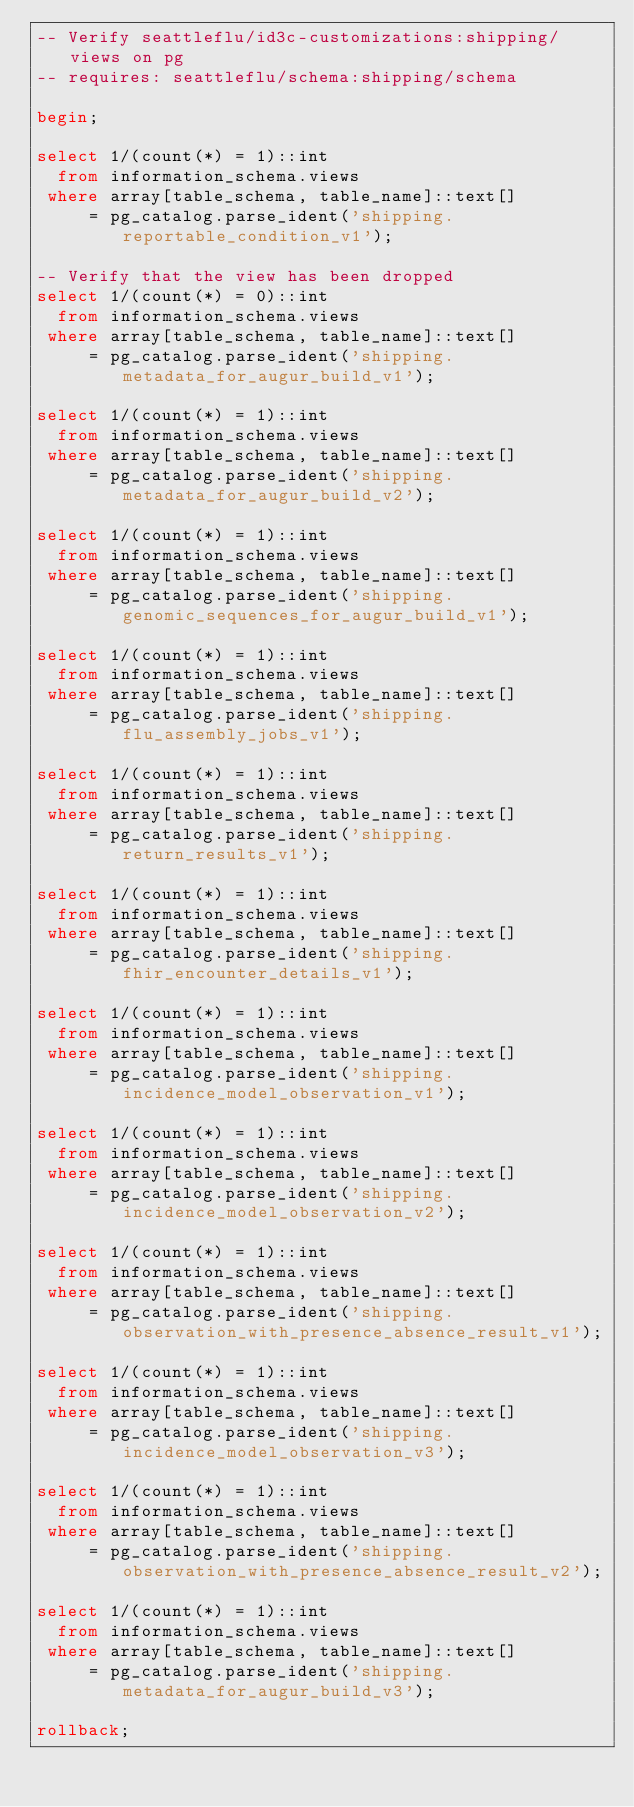Convert code to text. <code><loc_0><loc_0><loc_500><loc_500><_SQL_>-- Verify seattleflu/id3c-customizations:shipping/views on pg
-- requires: seattleflu/schema:shipping/schema

begin;

select 1/(count(*) = 1)::int
  from information_schema.views
 where array[table_schema, table_name]::text[]
     = pg_catalog.parse_ident('shipping.reportable_condition_v1');

-- Verify that the view has been dropped
select 1/(count(*) = 0)::int
  from information_schema.views
 where array[table_schema, table_name]::text[]
     = pg_catalog.parse_ident('shipping.metadata_for_augur_build_v1');

select 1/(count(*) = 1)::int
  from information_schema.views
 where array[table_schema, table_name]::text[]
     = pg_catalog.parse_ident('shipping.metadata_for_augur_build_v2');

select 1/(count(*) = 1)::int
  from information_schema.views
 where array[table_schema, table_name]::text[]
     = pg_catalog.parse_ident('shipping.genomic_sequences_for_augur_build_v1');

select 1/(count(*) = 1)::int
  from information_schema.views
 where array[table_schema, table_name]::text[]
     = pg_catalog.parse_ident('shipping.flu_assembly_jobs_v1');

select 1/(count(*) = 1)::int
  from information_schema.views
 where array[table_schema, table_name]::text[]
     = pg_catalog.parse_ident('shipping.return_results_v1');

select 1/(count(*) = 1)::int
  from information_schema.views
 where array[table_schema, table_name]::text[]
     = pg_catalog.parse_ident('shipping.fhir_encounter_details_v1');

select 1/(count(*) = 1)::int
  from information_schema.views
 where array[table_schema, table_name]::text[]
     = pg_catalog.parse_ident('shipping.incidence_model_observation_v1');

select 1/(count(*) = 1)::int
  from information_schema.views
 where array[table_schema, table_name]::text[]
     = pg_catalog.parse_ident('shipping.incidence_model_observation_v2');

select 1/(count(*) = 1)::int
  from information_schema.views
 where array[table_schema, table_name]::text[]
     = pg_catalog.parse_ident('shipping.observation_with_presence_absence_result_v1');

select 1/(count(*) = 1)::int
  from information_schema.views
 where array[table_schema, table_name]::text[]
     = pg_catalog.parse_ident('shipping.incidence_model_observation_v3');

select 1/(count(*) = 1)::int
  from information_schema.views
 where array[table_schema, table_name]::text[]
     = pg_catalog.parse_ident('shipping.observation_with_presence_absence_result_v2');

select 1/(count(*) = 1)::int
  from information_schema.views
 where array[table_schema, table_name]::text[]
     = pg_catalog.parse_ident('shipping.metadata_for_augur_build_v3');

rollback;
</code> 